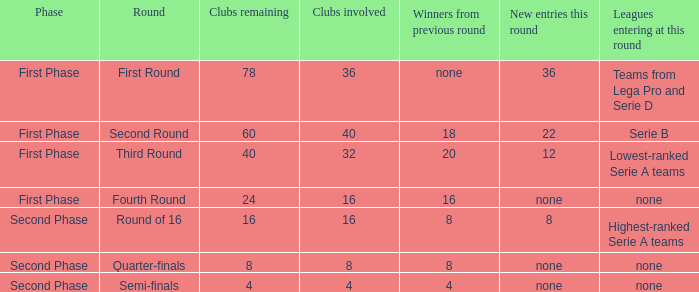If there are 8 clubs involved, what number would you discover from the winners of the previous round? 8.0. 